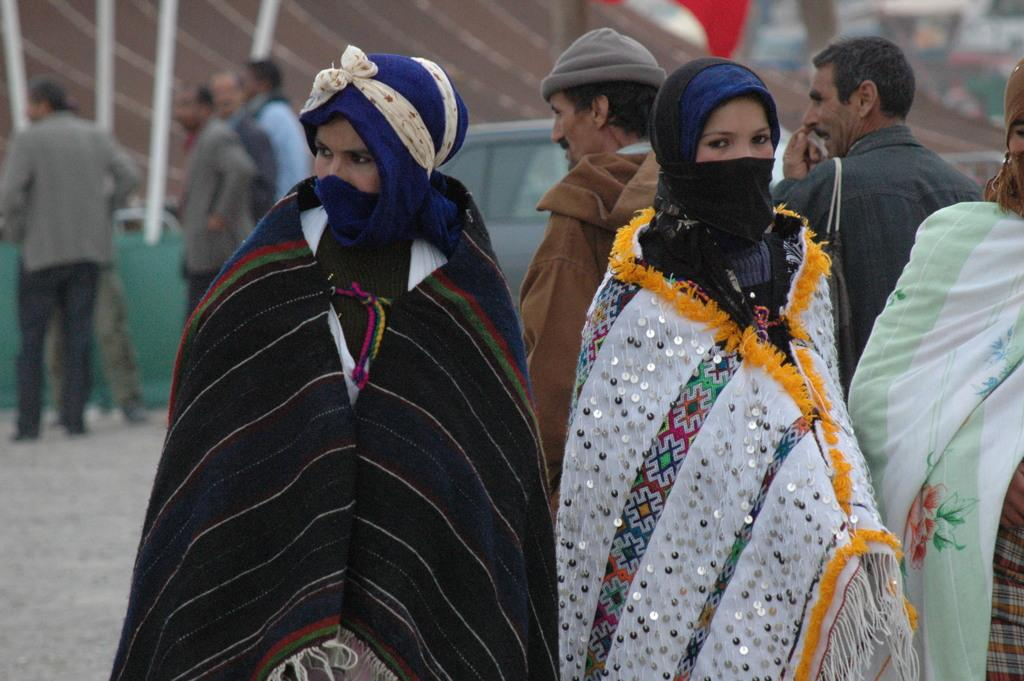What can be seen in the image involving multiple individuals? There is a group of people in the image. How are the people in the image dressed? The people are wearing different color dresses. What else is visible in the image besides the group of people? There is a vehicle visible in the image. Can you describe the background of the image? The background of the image is blurred. What type of silver object can be seen in the image? There is no silver object present in the image. Can you describe the behavior of the owl in the image? There is no owl present in the image. 